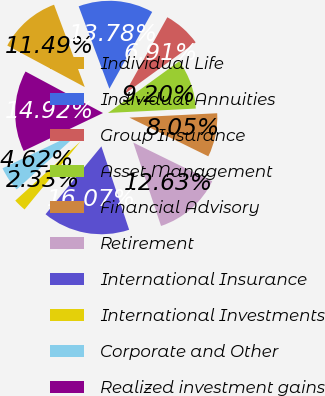Convert chart to OTSL. <chart><loc_0><loc_0><loc_500><loc_500><pie_chart><fcel>Individual Life<fcel>Individual Annuities<fcel>Group Insurance<fcel>Asset Management<fcel>Financial Advisory<fcel>Retirement<fcel>International Insurance<fcel>International Investments<fcel>Corporate and Other<fcel>Realized investment gains<nl><fcel>11.49%<fcel>13.78%<fcel>6.91%<fcel>9.2%<fcel>8.05%<fcel>12.63%<fcel>16.07%<fcel>2.33%<fcel>4.62%<fcel>14.92%<nl></chart> 